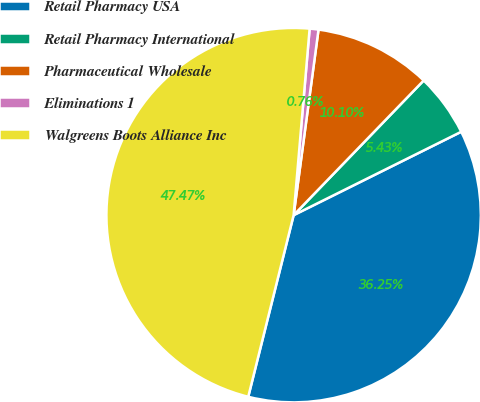Convert chart. <chart><loc_0><loc_0><loc_500><loc_500><pie_chart><fcel>Retail Pharmacy USA<fcel>Retail Pharmacy International<fcel>Pharmaceutical Wholesale<fcel>Eliminations 1<fcel>Walgreens Boots Alliance Inc<nl><fcel>36.25%<fcel>5.43%<fcel>10.1%<fcel>0.76%<fcel>47.47%<nl></chart> 